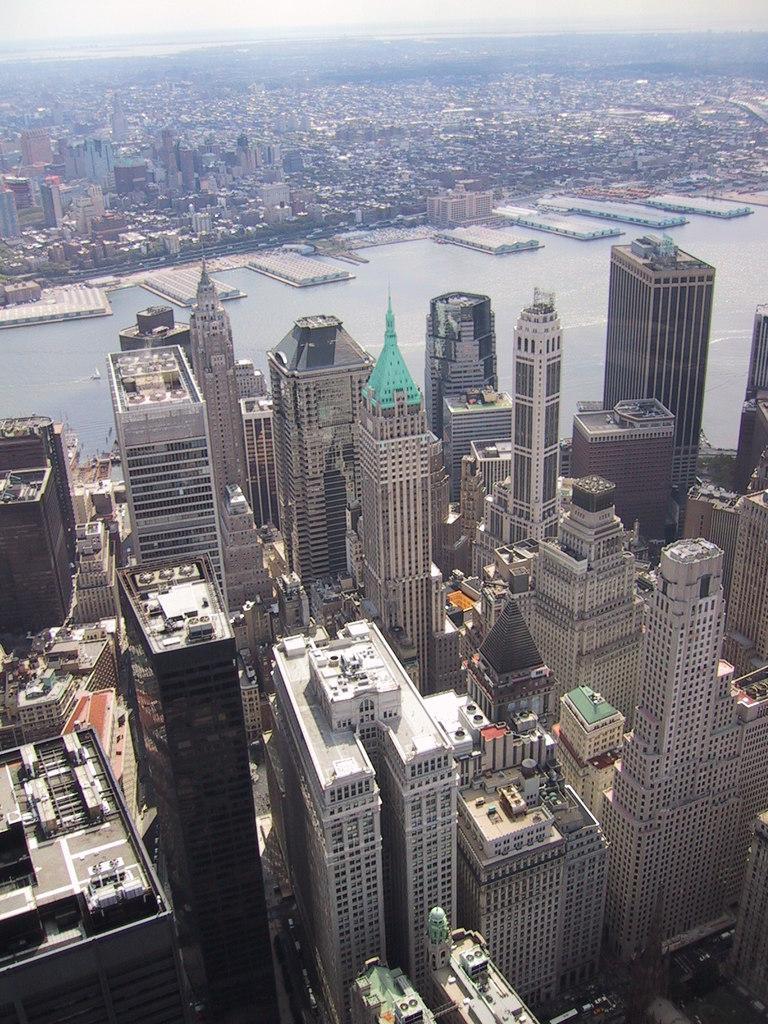How would you summarize this image in a sentence or two? There are many buildings in the foreground. In the middle there is water body. In the background there are many buildings. 